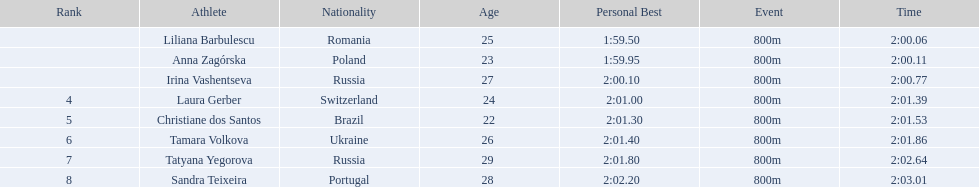Who were the athletes? Liliana Barbulescu, 2:00.06, Anna Zagórska, 2:00.11, Irina Vashentseva, 2:00.77, Laura Gerber, 2:01.39, Christiane dos Santos, 2:01.53, Tamara Volkova, 2:01.86, Tatyana Yegorova, 2:02.64, Sandra Teixeira, 2:03.01. Who received 2nd place? Anna Zagórska, 2:00.11. What was her time? 2:00.11. 